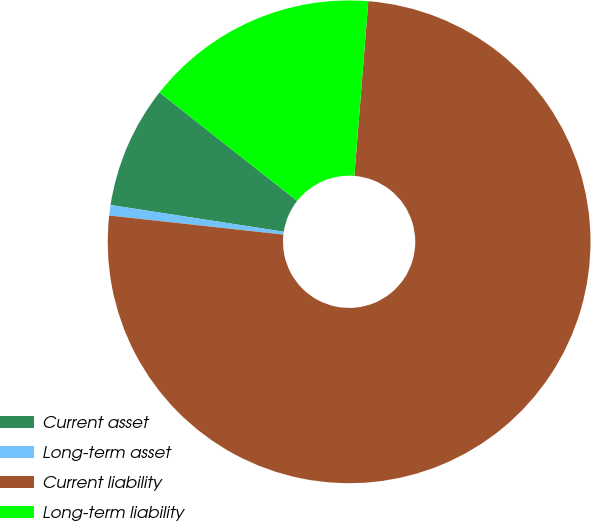<chart> <loc_0><loc_0><loc_500><loc_500><pie_chart><fcel>Current asset<fcel>Long-term asset<fcel>Current liability<fcel>Long-term liability<nl><fcel>8.18%<fcel>0.7%<fcel>75.47%<fcel>15.65%<nl></chart> 